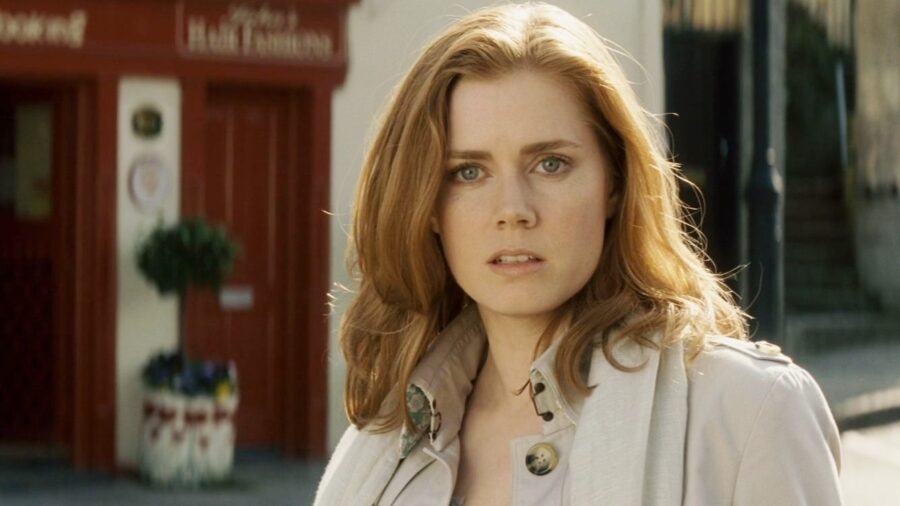The woman in the image seems like she's part of a larger story. What fantastical tale could you imagine for her? In a fantastical tale, the woman is actually a time-traveling guardian named Elara. Her mission is to protect the timeline from disruptions that could spell disaster. The red storefront is a secret portal to different eras, and the brooch she wears is a powerful artifact enabling her to navigate through time. Each mission requires her to blend into the period she enters, using her intuition and wits to uncover and thwart any threats. The plant in the window is not merely decor but a sentinel that signals when temporal anomalies are near. In this moment, captured in the image, Elara senses a disturbance and prepares for her next adventure, her mind already strategizing her next move to safeguard the flow of time. What could be causing the disturbance in the timeline that Elara has to fix? The disturbance in the timeline could be caused by a rogue historian who has discovered forbidden texts and aims to rewrite history for personal gain. By altering significant events, this individual intends to amass power and wealth, creating a reality where they rule supreme. The rogue's actions have begun to manifest as small but noticeable anomalies in different periods—famous disappearances, inexplicable natural events, and shifts in political powers. Elara must trace these subtle changes back to their source, thwart the rogue historian’s plans, and restore the natural order of history before these alterations become irreversible and plunge the world into chaos. What futuristic technology might Elara use on her missions? On her missions, Elara might use a range of advanced, futuristic technology. She could have a compact, holographic device that allows her to communicate with other guardians across time. Her brooch may double as a multi-functional gadget, providing immediate access to information about any era and disguising itself in different forms. She might also use a chronometer bracelet that can pinpoint and manipulate temporal rifts. Additionally, Elara could utilize nano-drones for surveillance and data collection, and a cloaking suit that adapts to the environment, making her virtually invisible as she navigates through different periods. Each piece of technology is designed to seamlessly integrate with her periods of operation, ensuring her missions remain covert and effective. Describe a climactic confrontation between Elara and the rogue historian. In a climactic confrontation, Elara tracks the rogue historian to a critical point in history where the final alterations are set to take place. The location is an ancient library hidden beneath the city, filled with rare manuscripts and forbidden texts. The air is thick with tension as Elara silently sneaks in, her cloaking suit blending with the shadowy surroundings. She spots the rogue, a figure draped in dark robes, pouring over an ancient scroll. As she approaches, the rogue senses her presence. A fierce battle ensues, with the rogue wielding dark, temporal magic and Elara countering with her futuristic tools and agility. The clash is intense, with bursts of energy illuminating the dim library. Books and artifacts scatter as they battle across the room. In a decisive moment, Elara uses her chronometer bracelet to create a temporal paradox, disrupting the rogue's powers and weakening them. With a final act of courage, she places the brooch on the rogue’s chest, neutralizing their abilities and restoring the timeline. The library resettles into a calm silence, and Elara stands victorious, ready to return to her role as guardian of time. What will Elara do next after this victory? After this monumental victory, Elara will ensure that the timeline has been fully restored and that all anomalies are corrected. She will return the forbidden texts to their rightful place, ensuring they remain hidden from those who wish to misuse them. Elara might then take a brief moment of respite, reflecting on the significance of her journey and the lives she has impacted. However, her duty as a guardian is never-ending. Soon, she will receive a new mission, a fresh disturbance in the flow of time. Armed with her experiences and unyielding dedication, Elara will once again step through the portal, ready to face whatever new challenges the tapestry of history weaves her way. Her resolve to protect the timeline remains steadfast, and she knows that her vigilance ensures a stable and prosperous future for all. 